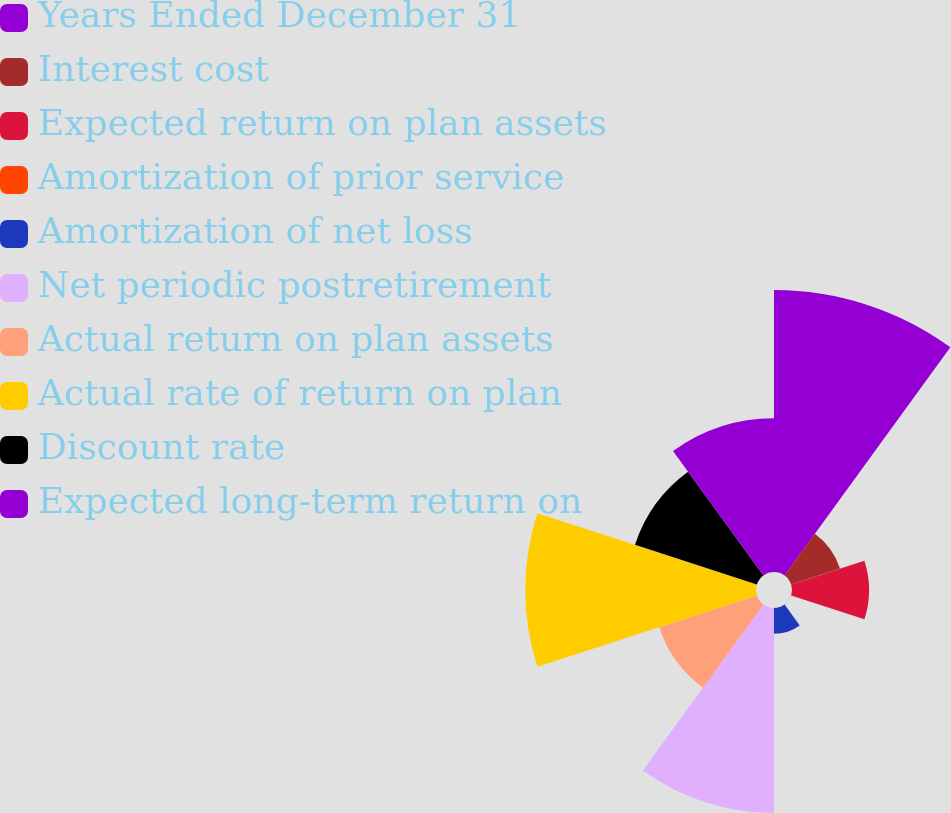Convert chart to OTSL. <chart><loc_0><loc_0><loc_500><loc_500><pie_chart><fcel>Years Ended December 31<fcel>Interest cost<fcel>Expected return on plan assets<fcel>Amortization of prior service<fcel>Amortization of net loss<fcel>Net periodic postretirement<fcel>Actual return on plan assets<fcel>Actual rate of return on plan<fcel>Discount rate<fcel>Expected long-term return on<nl><fcel>22.44%<fcel>4.09%<fcel>6.13%<fcel>0.01%<fcel>2.05%<fcel>16.32%<fcel>8.17%<fcel>18.36%<fcel>10.2%<fcel>12.24%<nl></chart> 